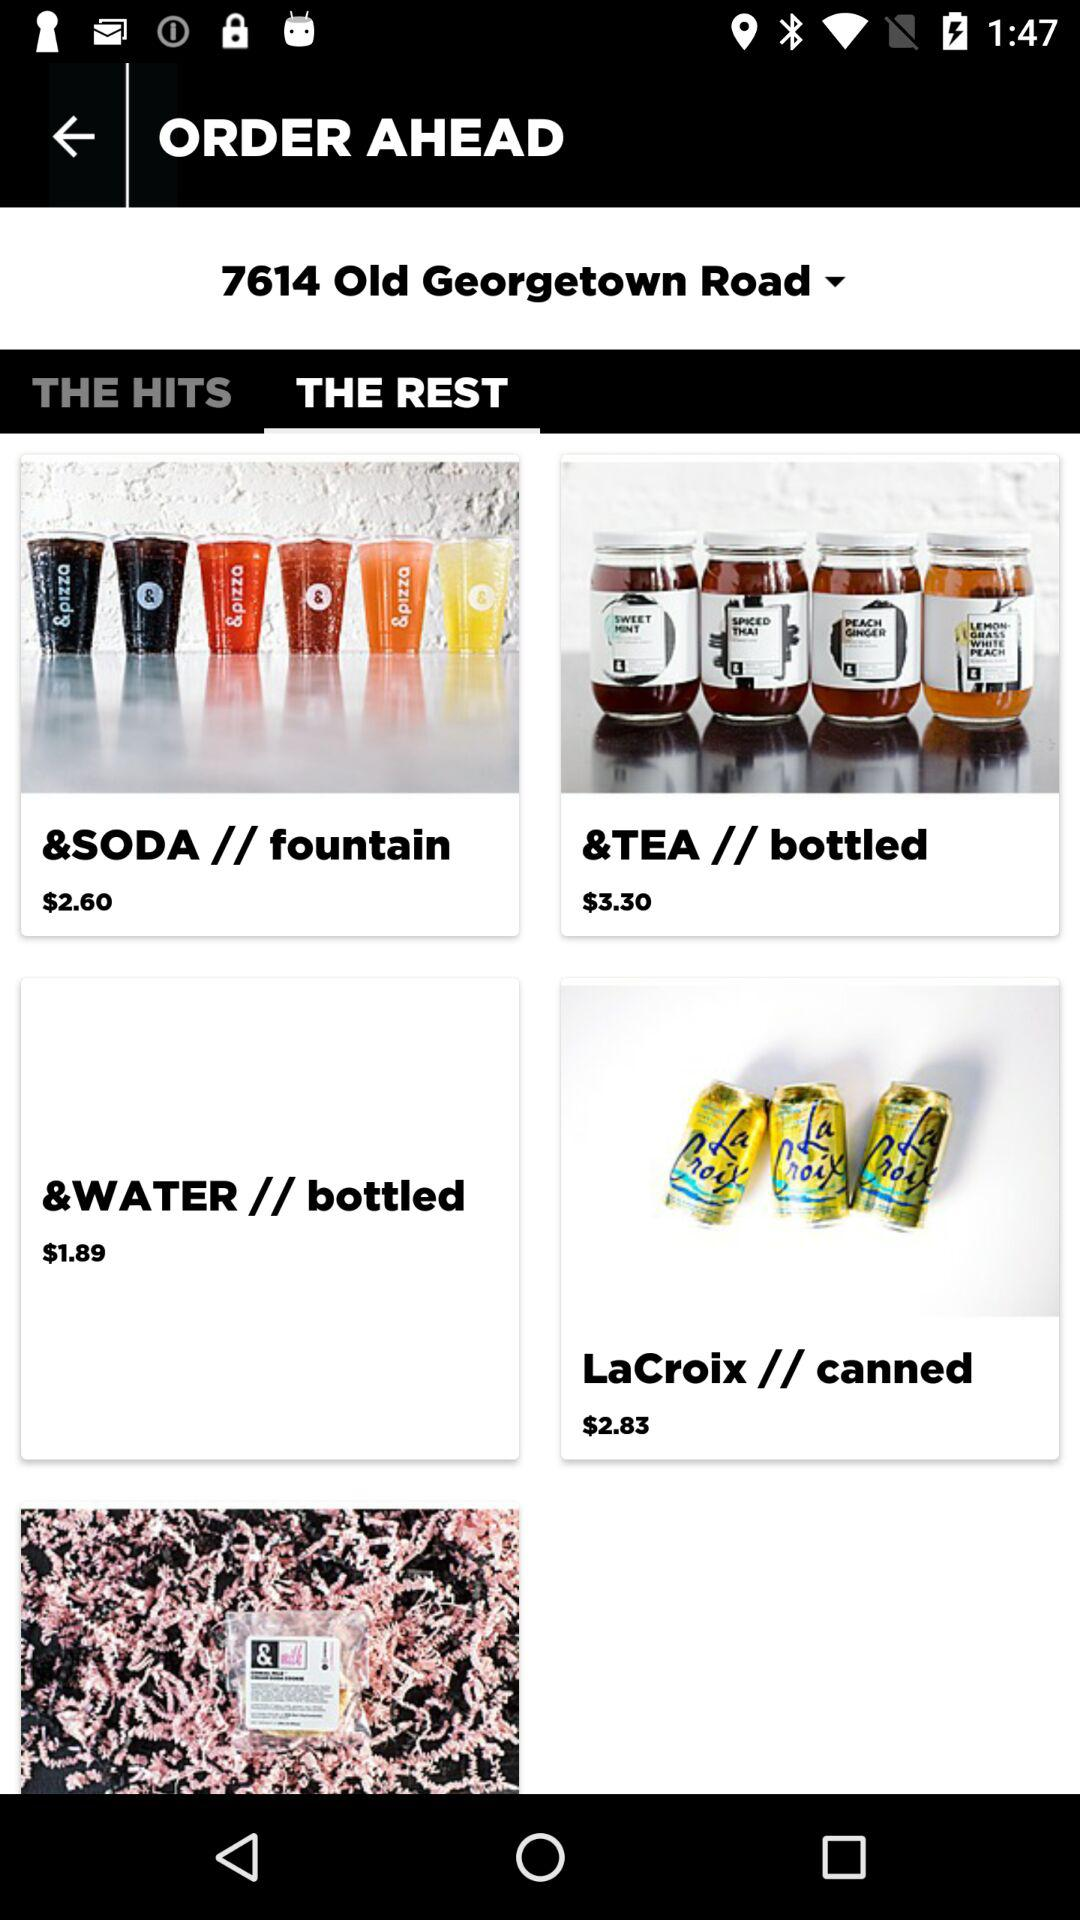What is the price of a tea bottle? The price of a tea bottle is $3.30. 